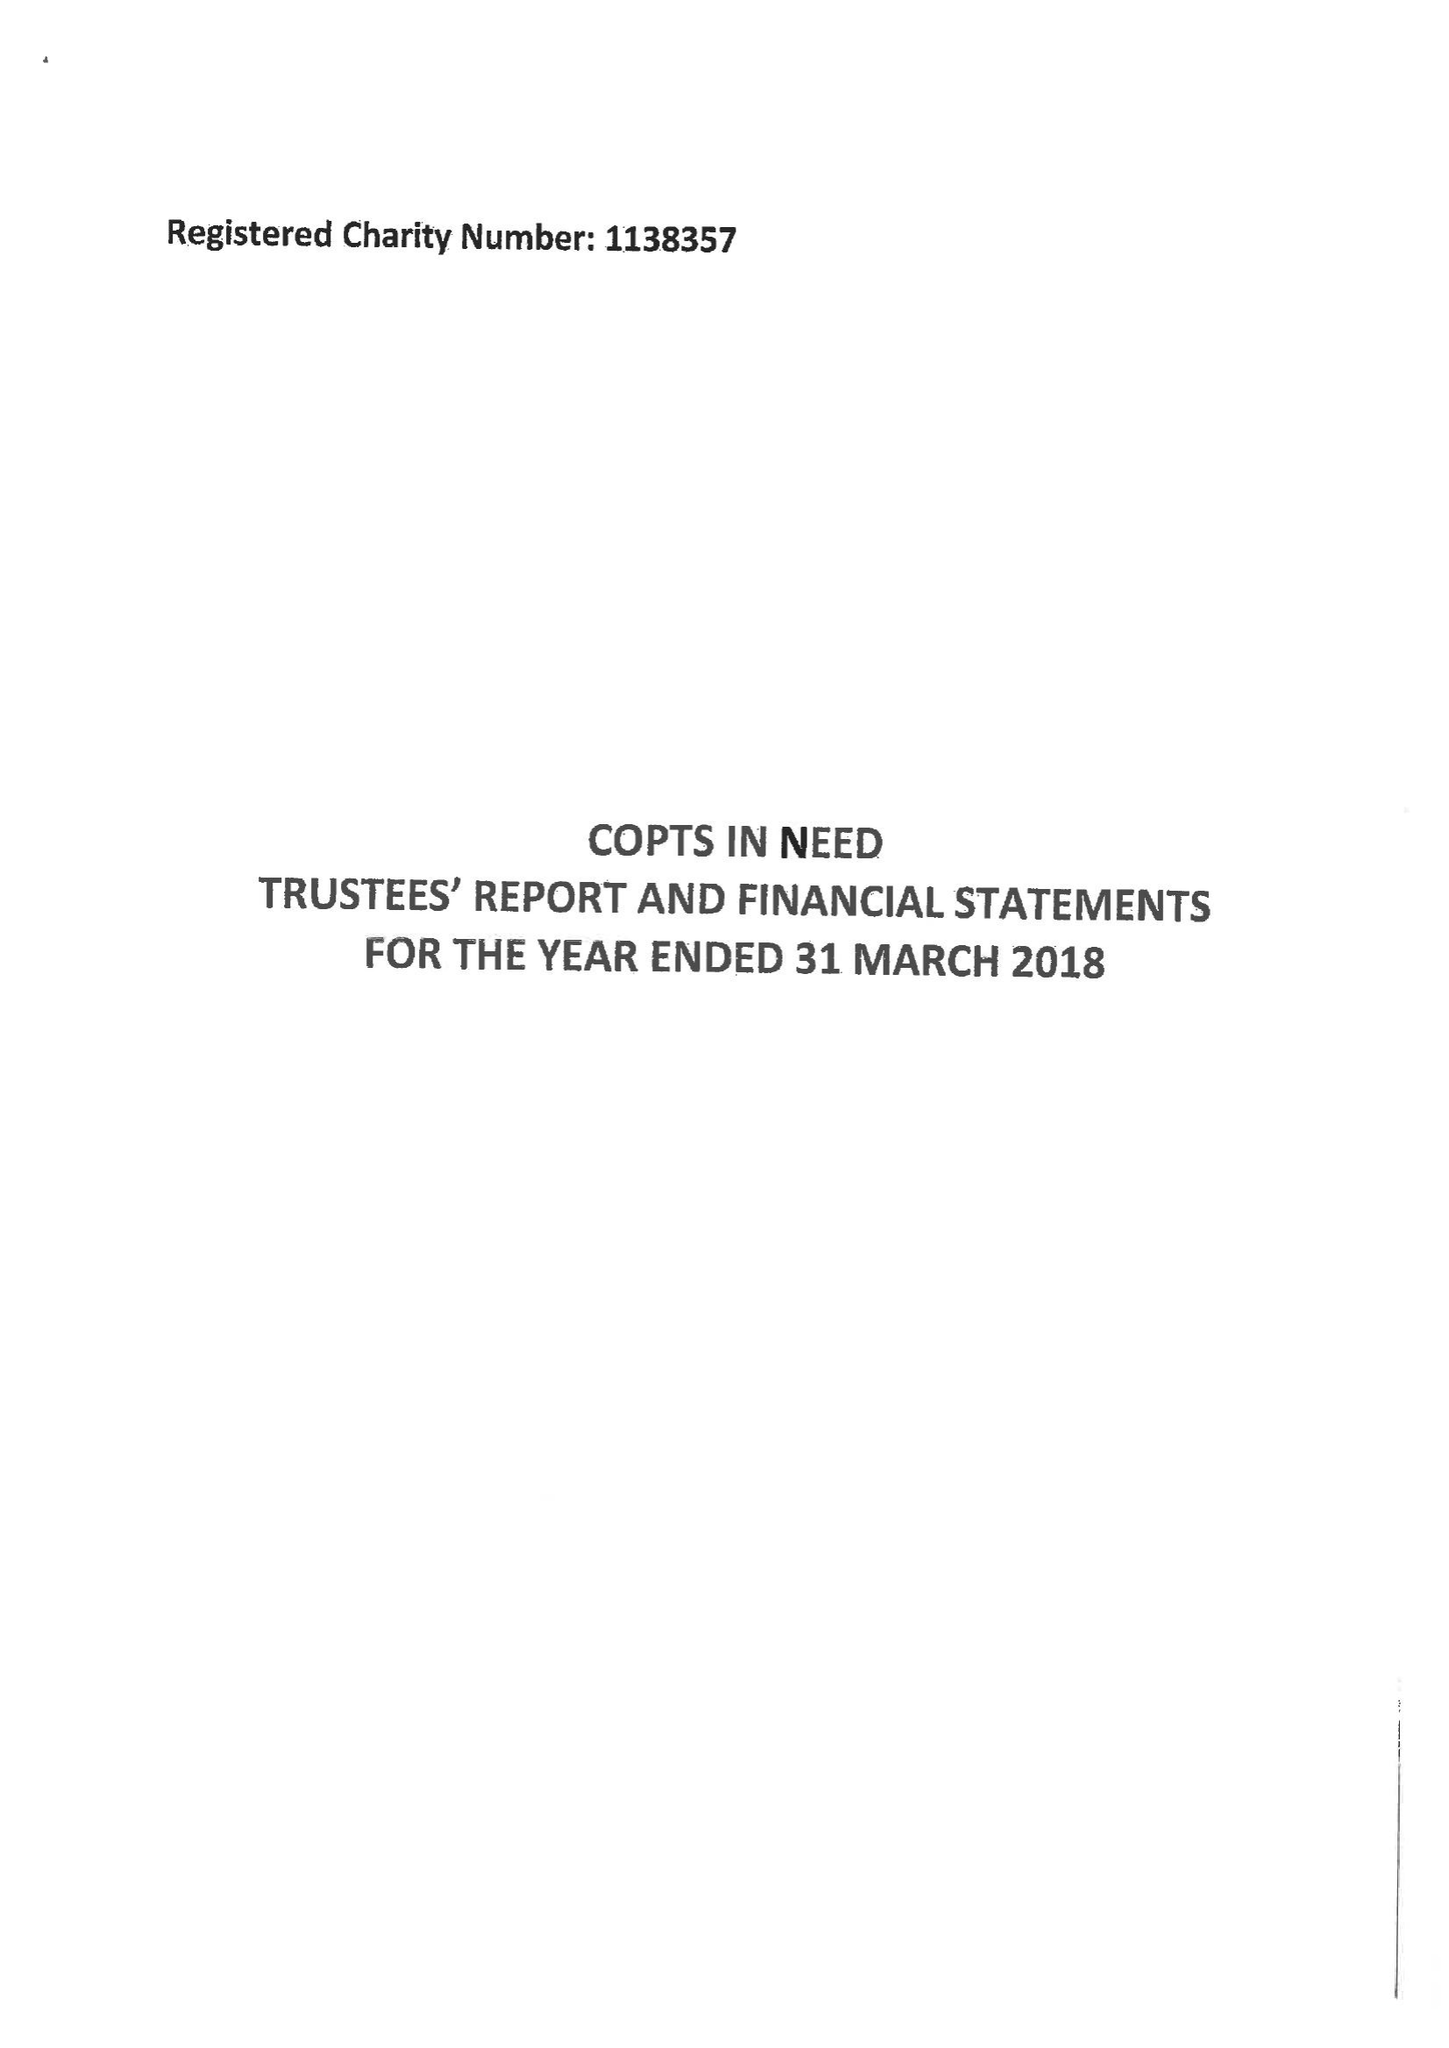What is the value for the address__post_town?
Answer the question using a single word or phrase. BILLINGHAM 